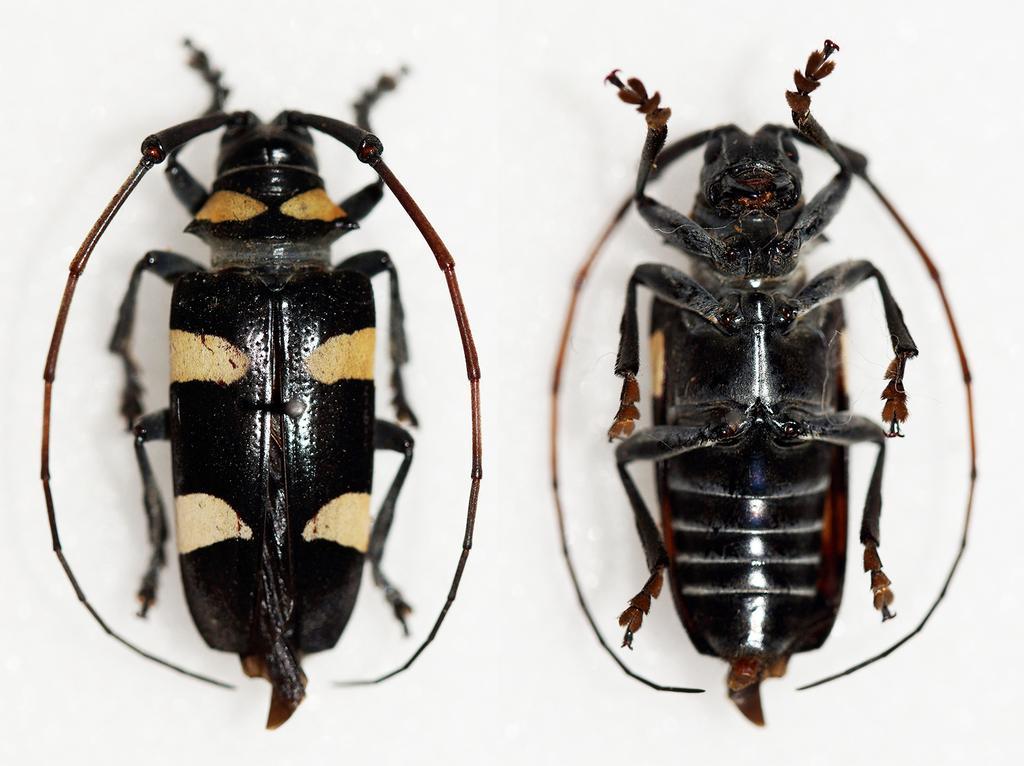Could you give a brief overview of what you see in this image? In this picture on a white surface we can see two longhorn beetles. 